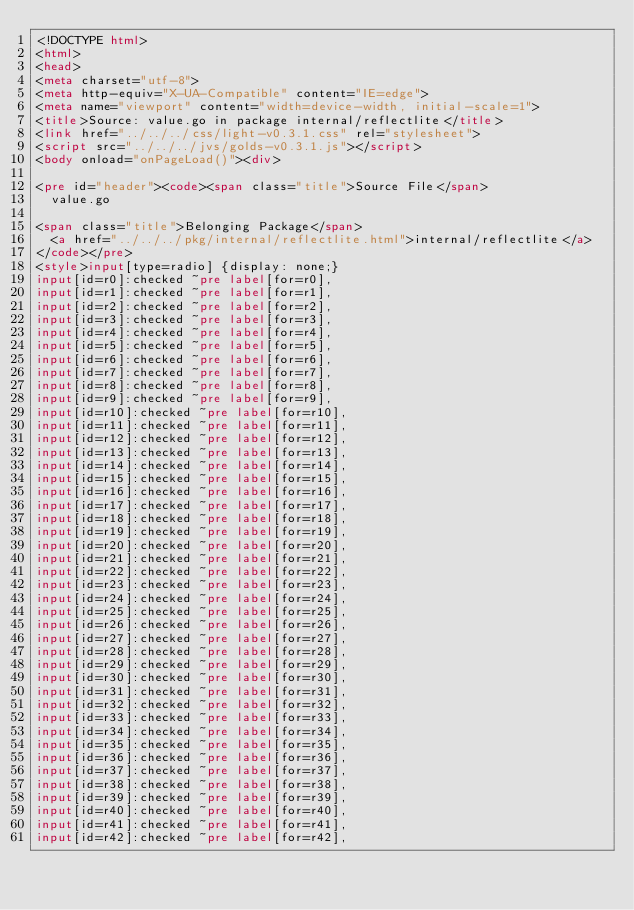Convert code to text. <code><loc_0><loc_0><loc_500><loc_500><_HTML_><!DOCTYPE html>
<html>
<head>
<meta charset="utf-8">
<meta http-equiv="X-UA-Compatible" content="IE=edge">
<meta name="viewport" content="width=device-width, initial-scale=1">
<title>Source: value.go in package internal/reflectlite</title>
<link href="../../../css/light-v0.3.1.css" rel="stylesheet">
<script src="../../../jvs/golds-v0.3.1.js"></script>
<body onload="onPageLoad()"><div>

<pre id="header"><code><span class="title">Source File</span>
	value.go

<span class="title">Belonging Package</span>
	<a href="../../../pkg/internal/reflectlite.html">internal/reflectlite</a>
</code></pre>
<style>input[type=radio] {display: none;}
input[id=r0]:checked ~pre label[for=r0],
input[id=r1]:checked ~pre label[for=r1],
input[id=r2]:checked ~pre label[for=r2],
input[id=r3]:checked ~pre label[for=r3],
input[id=r4]:checked ~pre label[for=r4],
input[id=r5]:checked ~pre label[for=r5],
input[id=r6]:checked ~pre label[for=r6],
input[id=r7]:checked ~pre label[for=r7],
input[id=r8]:checked ~pre label[for=r8],
input[id=r9]:checked ~pre label[for=r9],
input[id=r10]:checked ~pre label[for=r10],
input[id=r11]:checked ~pre label[for=r11],
input[id=r12]:checked ~pre label[for=r12],
input[id=r13]:checked ~pre label[for=r13],
input[id=r14]:checked ~pre label[for=r14],
input[id=r15]:checked ~pre label[for=r15],
input[id=r16]:checked ~pre label[for=r16],
input[id=r17]:checked ~pre label[for=r17],
input[id=r18]:checked ~pre label[for=r18],
input[id=r19]:checked ~pre label[for=r19],
input[id=r20]:checked ~pre label[for=r20],
input[id=r21]:checked ~pre label[for=r21],
input[id=r22]:checked ~pre label[for=r22],
input[id=r23]:checked ~pre label[for=r23],
input[id=r24]:checked ~pre label[for=r24],
input[id=r25]:checked ~pre label[for=r25],
input[id=r26]:checked ~pre label[for=r26],
input[id=r27]:checked ~pre label[for=r27],
input[id=r28]:checked ~pre label[for=r28],
input[id=r29]:checked ~pre label[for=r29],
input[id=r30]:checked ~pre label[for=r30],
input[id=r31]:checked ~pre label[for=r31],
input[id=r32]:checked ~pre label[for=r32],
input[id=r33]:checked ~pre label[for=r33],
input[id=r34]:checked ~pre label[for=r34],
input[id=r35]:checked ~pre label[for=r35],
input[id=r36]:checked ~pre label[for=r36],
input[id=r37]:checked ~pre label[for=r37],
input[id=r38]:checked ~pre label[for=r38],
input[id=r39]:checked ~pre label[for=r39],
input[id=r40]:checked ~pre label[for=r40],
input[id=r41]:checked ~pre label[for=r41],
input[id=r42]:checked ~pre label[for=r42],</code> 